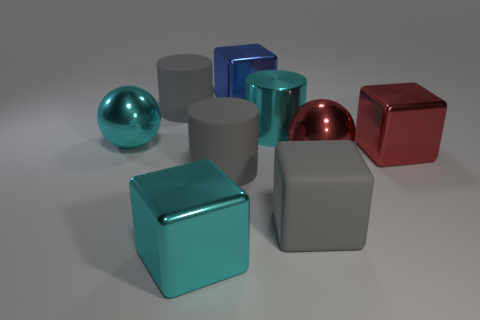Add 1 large red things. How many objects exist? 10 Subtract all blocks. How many objects are left? 5 Subtract all large brown rubber spheres. Subtract all large red metal balls. How many objects are left? 8 Add 6 blue blocks. How many blue blocks are left? 7 Add 1 tiny brown cubes. How many tiny brown cubes exist? 1 Subtract 0 gray balls. How many objects are left? 9 